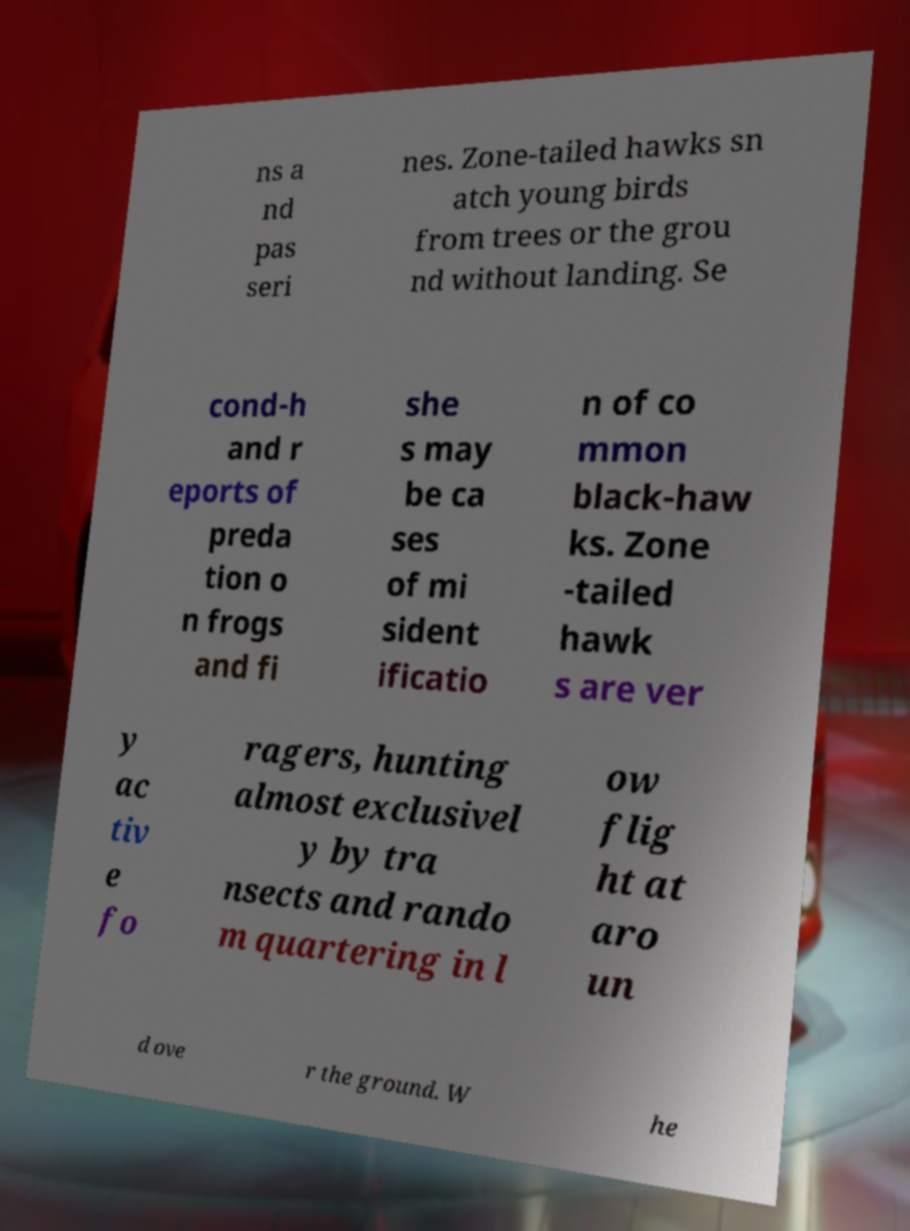Could you extract and type out the text from this image? ns a nd pas seri nes. Zone-tailed hawks sn atch young birds from trees or the grou nd without landing. Se cond-h and r eports of preda tion o n frogs and fi she s may be ca ses of mi sident ificatio n of co mmon black-haw ks. Zone -tailed hawk s are ver y ac tiv e fo ragers, hunting almost exclusivel y by tra nsects and rando m quartering in l ow flig ht at aro un d ove r the ground. W he 